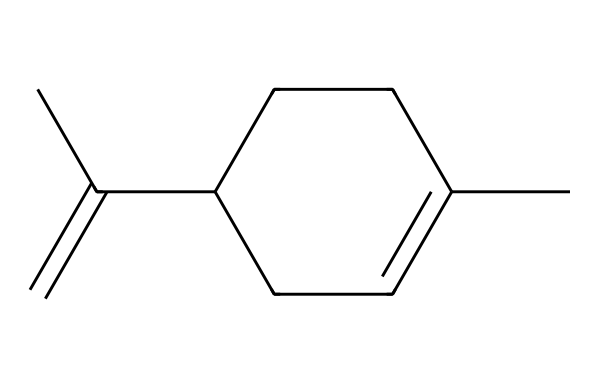What is the molecular formula of limonene? To find the molecular formula, we count the number of carbon (C) and hydrogen (H) atoms in the structure. The SMILES representation indicates 10 carbons and 16 hydrogens. Thus, the molecular formula is C10H16.
Answer: C10H16 How many rings are present in the structure? By analyzing the structure, we can see that there is one cyclohexane ring indicated by the "C1" and "CC1" notation in the SMILES. Therefore, there is one ring present.
Answer: 1 What type of isomerism does limonene exhibit? Limonene is a type of monoterpene that can exist as two geometric isomers, namely D-limonene and L-limonene, due to the presence of the double bond. Hence, it exhibits geometric isomerism.
Answer: geometric isomerism What characteristic scent is limonene associated with? Limonene is widely known for its strong citrus scent, which is a notable signature of oranges and lemons. Therefore, it is characterized by a citrus scent.
Answer: citrus How does the double bond influence limonene's aroma? The presence of a double bond in the structure allows for increased volatility and reactivity, which contributes significantly to limonene's distinct and pleasant citrus aroma. This atomic arrangement plays a crucial role in its olfactory profile.
Answer: volatility What functional group is present in limonene? In limonene, there is no hydroxyl (-OH) or carboxyl (-COOH) group, but it does contain a double bond (alkene) within its hydrocarbon framework, marking it as a hydrophobic compound. Thus, the presence of a double bond is characteristic of alkenes.
Answer: alkene 